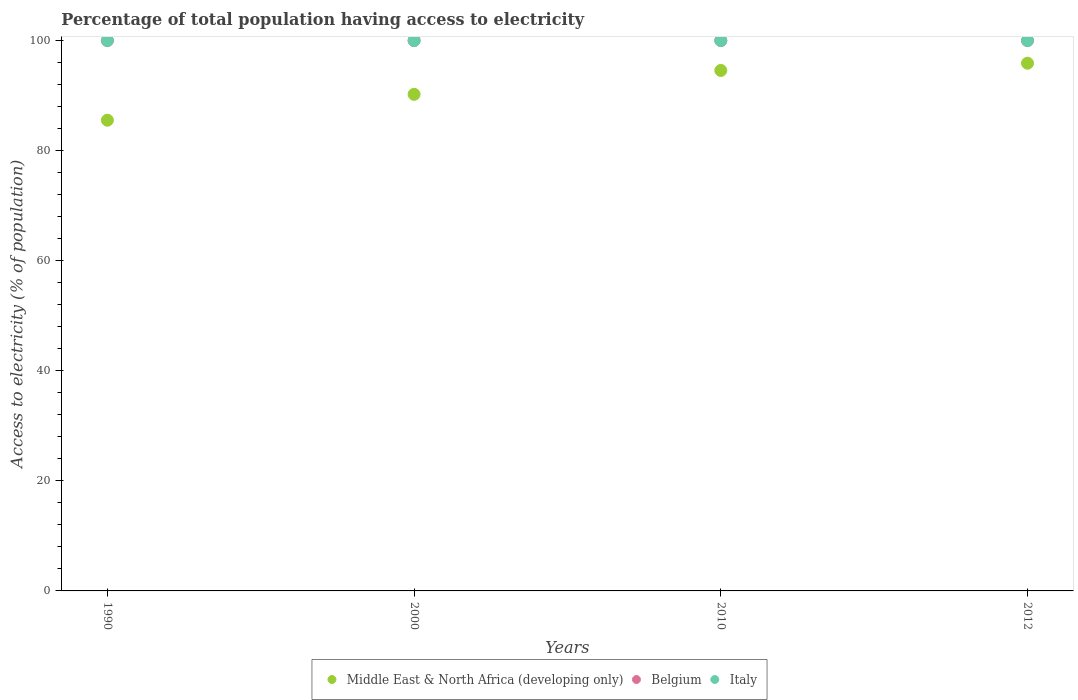Is the number of dotlines equal to the number of legend labels?
Make the answer very short. Yes. What is the percentage of population that have access to electricity in Middle East & North Africa (developing only) in 1990?
Offer a very short reply. 85.53. Across all years, what is the maximum percentage of population that have access to electricity in Italy?
Your answer should be compact. 100. Across all years, what is the minimum percentage of population that have access to electricity in Italy?
Ensure brevity in your answer.  100. In which year was the percentage of population that have access to electricity in Italy minimum?
Provide a short and direct response. 1990. What is the total percentage of population that have access to electricity in Middle East & North Africa (developing only) in the graph?
Offer a very short reply. 366.21. What is the difference between the percentage of population that have access to electricity in Middle East & North Africa (developing only) in 2010 and that in 2012?
Your answer should be very brief. -1.32. What is the difference between the percentage of population that have access to electricity in Middle East & North Africa (developing only) in 1990 and the percentage of population that have access to electricity in Italy in 2010?
Make the answer very short. -14.47. In how many years, is the percentage of population that have access to electricity in Belgium greater than 40 %?
Provide a succinct answer. 4. Is the percentage of population that have access to electricity in Belgium in 2000 less than that in 2010?
Ensure brevity in your answer.  No. What is the difference between the highest and the second highest percentage of population that have access to electricity in Italy?
Keep it short and to the point. 0. Is the percentage of population that have access to electricity in Belgium strictly greater than the percentage of population that have access to electricity in Middle East & North Africa (developing only) over the years?
Offer a very short reply. Yes. Are the values on the major ticks of Y-axis written in scientific E-notation?
Provide a succinct answer. No. Does the graph contain grids?
Make the answer very short. No. Where does the legend appear in the graph?
Offer a terse response. Bottom center. How many legend labels are there?
Give a very brief answer. 3. What is the title of the graph?
Keep it short and to the point. Percentage of total population having access to electricity. What is the label or title of the X-axis?
Offer a terse response. Years. What is the label or title of the Y-axis?
Ensure brevity in your answer.  Access to electricity (% of population). What is the Access to electricity (% of population) of Middle East & North Africa (developing only) in 1990?
Offer a terse response. 85.53. What is the Access to electricity (% of population) of Belgium in 1990?
Your answer should be very brief. 100. What is the Access to electricity (% of population) of Middle East & North Africa (developing only) in 2000?
Ensure brevity in your answer.  90.23. What is the Access to electricity (% of population) of Italy in 2000?
Offer a very short reply. 100. What is the Access to electricity (% of population) in Middle East & North Africa (developing only) in 2010?
Offer a terse response. 94.57. What is the Access to electricity (% of population) in Belgium in 2010?
Make the answer very short. 100. What is the Access to electricity (% of population) in Middle East & North Africa (developing only) in 2012?
Ensure brevity in your answer.  95.88. What is the Access to electricity (% of population) in Belgium in 2012?
Your answer should be compact. 100. What is the Access to electricity (% of population) in Italy in 2012?
Offer a terse response. 100. Across all years, what is the maximum Access to electricity (% of population) of Middle East & North Africa (developing only)?
Give a very brief answer. 95.88. Across all years, what is the maximum Access to electricity (% of population) of Belgium?
Offer a very short reply. 100. Across all years, what is the minimum Access to electricity (% of population) of Middle East & North Africa (developing only)?
Offer a very short reply. 85.53. Across all years, what is the minimum Access to electricity (% of population) in Belgium?
Your answer should be compact. 100. What is the total Access to electricity (% of population) of Middle East & North Africa (developing only) in the graph?
Ensure brevity in your answer.  366.21. What is the total Access to electricity (% of population) in Belgium in the graph?
Ensure brevity in your answer.  400. What is the total Access to electricity (% of population) of Italy in the graph?
Make the answer very short. 400. What is the difference between the Access to electricity (% of population) in Middle East & North Africa (developing only) in 1990 and that in 2000?
Give a very brief answer. -4.7. What is the difference between the Access to electricity (% of population) of Belgium in 1990 and that in 2000?
Ensure brevity in your answer.  0. What is the difference between the Access to electricity (% of population) in Italy in 1990 and that in 2000?
Your answer should be very brief. 0. What is the difference between the Access to electricity (% of population) of Middle East & North Africa (developing only) in 1990 and that in 2010?
Provide a short and direct response. -9.04. What is the difference between the Access to electricity (% of population) of Belgium in 1990 and that in 2010?
Give a very brief answer. 0. What is the difference between the Access to electricity (% of population) in Middle East & North Africa (developing only) in 1990 and that in 2012?
Ensure brevity in your answer.  -10.36. What is the difference between the Access to electricity (% of population) of Belgium in 1990 and that in 2012?
Offer a terse response. 0. What is the difference between the Access to electricity (% of population) of Italy in 1990 and that in 2012?
Make the answer very short. 0. What is the difference between the Access to electricity (% of population) in Middle East & North Africa (developing only) in 2000 and that in 2010?
Your answer should be compact. -4.34. What is the difference between the Access to electricity (% of population) of Belgium in 2000 and that in 2010?
Ensure brevity in your answer.  0. What is the difference between the Access to electricity (% of population) of Middle East & North Africa (developing only) in 2000 and that in 2012?
Make the answer very short. -5.65. What is the difference between the Access to electricity (% of population) of Belgium in 2000 and that in 2012?
Your answer should be compact. 0. What is the difference between the Access to electricity (% of population) of Middle East & North Africa (developing only) in 2010 and that in 2012?
Provide a succinct answer. -1.32. What is the difference between the Access to electricity (% of population) in Middle East & North Africa (developing only) in 1990 and the Access to electricity (% of population) in Belgium in 2000?
Give a very brief answer. -14.47. What is the difference between the Access to electricity (% of population) of Middle East & North Africa (developing only) in 1990 and the Access to electricity (% of population) of Italy in 2000?
Your response must be concise. -14.47. What is the difference between the Access to electricity (% of population) of Belgium in 1990 and the Access to electricity (% of population) of Italy in 2000?
Your answer should be compact. 0. What is the difference between the Access to electricity (% of population) of Middle East & North Africa (developing only) in 1990 and the Access to electricity (% of population) of Belgium in 2010?
Give a very brief answer. -14.47. What is the difference between the Access to electricity (% of population) in Middle East & North Africa (developing only) in 1990 and the Access to electricity (% of population) in Italy in 2010?
Your response must be concise. -14.47. What is the difference between the Access to electricity (% of population) of Middle East & North Africa (developing only) in 1990 and the Access to electricity (% of population) of Belgium in 2012?
Give a very brief answer. -14.47. What is the difference between the Access to electricity (% of population) in Middle East & North Africa (developing only) in 1990 and the Access to electricity (% of population) in Italy in 2012?
Your answer should be very brief. -14.47. What is the difference between the Access to electricity (% of population) in Belgium in 1990 and the Access to electricity (% of population) in Italy in 2012?
Your response must be concise. 0. What is the difference between the Access to electricity (% of population) in Middle East & North Africa (developing only) in 2000 and the Access to electricity (% of population) in Belgium in 2010?
Your response must be concise. -9.77. What is the difference between the Access to electricity (% of population) in Middle East & North Africa (developing only) in 2000 and the Access to electricity (% of population) in Italy in 2010?
Keep it short and to the point. -9.77. What is the difference between the Access to electricity (% of population) in Middle East & North Africa (developing only) in 2000 and the Access to electricity (% of population) in Belgium in 2012?
Provide a short and direct response. -9.77. What is the difference between the Access to electricity (% of population) of Middle East & North Africa (developing only) in 2000 and the Access to electricity (% of population) of Italy in 2012?
Offer a very short reply. -9.77. What is the difference between the Access to electricity (% of population) in Belgium in 2000 and the Access to electricity (% of population) in Italy in 2012?
Your answer should be very brief. 0. What is the difference between the Access to electricity (% of population) in Middle East & North Africa (developing only) in 2010 and the Access to electricity (% of population) in Belgium in 2012?
Keep it short and to the point. -5.43. What is the difference between the Access to electricity (% of population) in Middle East & North Africa (developing only) in 2010 and the Access to electricity (% of population) in Italy in 2012?
Offer a very short reply. -5.43. What is the difference between the Access to electricity (% of population) in Belgium in 2010 and the Access to electricity (% of population) in Italy in 2012?
Ensure brevity in your answer.  0. What is the average Access to electricity (% of population) in Middle East & North Africa (developing only) per year?
Your answer should be compact. 91.55. What is the average Access to electricity (% of population) in Belgium per year?
Your answer should be very brief. 100. In the year 1990, what is the difference between the Access to electricity (% of population) of Middle East & North Africa (developing only) and Access to electricity (% of population) of Belgium?
Your answer should be very brief. -14.47. In the year 1990, what is the difference between the Access to electricity (% of population) of Middle East & North Africa (developing only) and Access to electricity (% of population) of Italy?
Your answer should be compact. -14.47. In the year 2000, what is the difference between the Access to electricity (% of population) in Middle East & North Africa (developing only) and Access to electricity (% of population) in Belgium?
Keep it short and to the point. -9.77. In the year 2000, what is the difference between the Access to electricity (% of population) of Middle East & North Africa (developing only) and Access to electricity (% of population) of Italy?
Give a very brief answer. -9.77. In the year 2000, what is the difference between the Access to electricity (% of population) in Belgium and Access to electricity (% of population) in Italy?
Ensure brevity in your answer.  0. In the year 2010, what is the difference between the Access to electricity (% of population) of Middle East & North Africa (developing only) and Access to electricity (% of population) of Belgium?
Keep it short and to the point. -5.43. In the year 2010, what is the difference between the Access to electricity (% of population) of Middle East & North Africa (developing only) and Access to electricity (% of population) of Italy?
Provide a succinct answer. -5.43. In the year 2012, what is the difference between the Access to electricity (% of population) of Middle East & North Africa (developing only) and Access to electricity (% of population) of Belgium?
Offer a very short reply. -4.12. In the year 2012, what is the difference between the Access to electricity (% of population) in Middle East & North Africa (developing only) and Access to electricity (% of population) in Italy?
Offer a terse response. -4.12. In the year 2012, what is the difference between the Access to electricity (% of population) in Belgium and Access to electricity (% of population) in Italy?
Your answer should be compact. 0. What is the ratio of the Access to electricity (% of population) in Middle East & North Africa (developing only) in 1990 to that in 2000?
Give a very brief answer. 0.95. What is the ratio of the Access to electricity (% of population) in Italy in 1990 to that in 2000?
Your response must be concise. 1. What is the ratio of the Access to electricity (% of population) of Middle East & North Africa (developing only) in 1990 to that in 2010?
Your answer should be compact. 0.9. What is the ratio of the Access to electricity (% of population) of Belgium in 1990 to that in 2010?
Ensure brevity in your answer.  1. What is the ratio of the Access to electricity (% of population) in Middle East & North Africa (developing only) in 1990 to that in 2012?
Provide a short and direct response. 0.89. What is the ratio of the Access to electricity (% of population) of Italy in 1990 to that in 2012?
Ensure brevity in your answer.  1. What is the ratio of the Access to electricity (% of population) of Middle East & North Africa (developing only) in 2000 to that in 2010?
Ensure brevity in your answer.  0.95. What is the ratio of the Access to electricity (% of population) in Belgium in 2000 to that in 2010?
Your response must be concise. 1. What is the ratio of the Access to electricity (% of population) in Middle East & North Africa (developing only) in 2000 to that in 2012?
Make the answer very short. 0.94. What is the ratio of the Access to electricity (% of population) in Middle East & North Africa (developing only) in 2010 to that in 2012?
Offer a very short reply. 0.99. What is the difference between the highest and the second highest Access to electricity (% of population) in Middle East & North Africa (developing only)?
Make the answer very short. 1.32. What is the difference between the highest and the second highest Access to electricity (% of population) of Belgium?
Provide a succinct answer. 0. What is the difference between the highest and the lowest Access to electricity (% of population) in Middle East & North Africa (developing only)?
Keep it short and to the point. 10.36. What is the difference between the highest and the lowest Access to electricity (% of population) of Belgium?
Your answer should be compact. 0. 